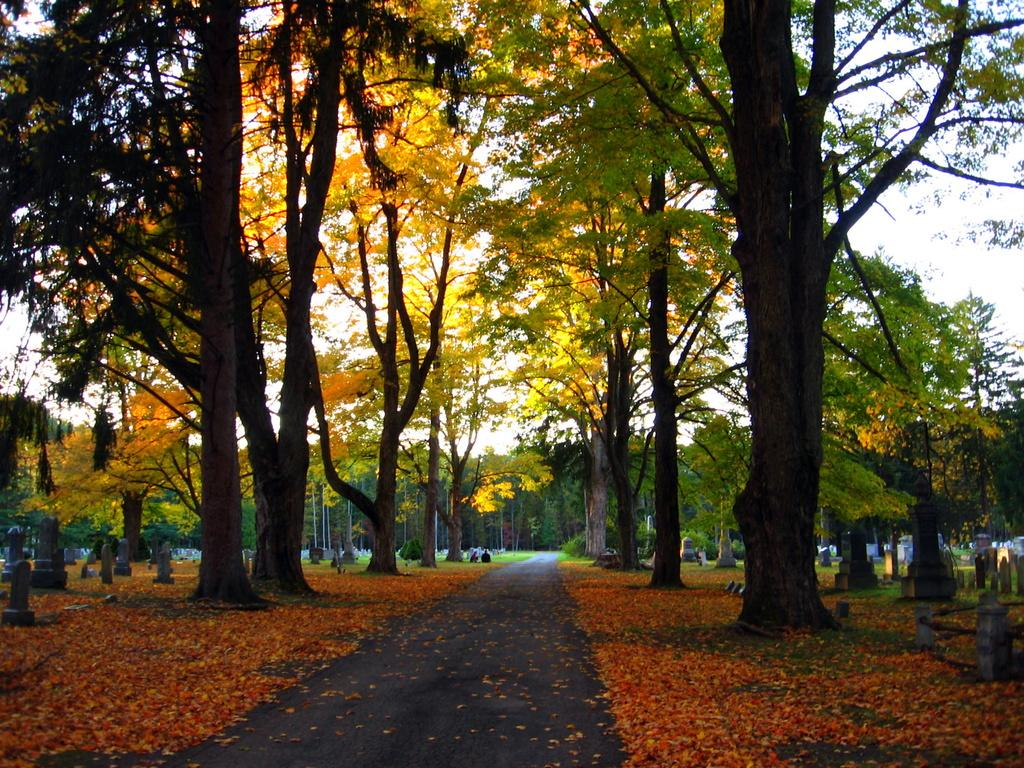What is on the ground in the image? There are dry leaves on the ground in the image. What type of vegetation can be seen in the image? There are trees in the image. Can you see a monkey climbing one of the trees in the image? There is no monkey present in the image; it only features dry leaves on the ground and trees. What type of structure can be seen in the image? There is no structure present in the image; it only features dry leaves on the ground and trees. 